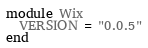Convert code to text. <code><loc_0><loc_0><loc_500><loc_500><_Ruby_>module Wix
  VERSION = "0.0.5"
end
</code> 